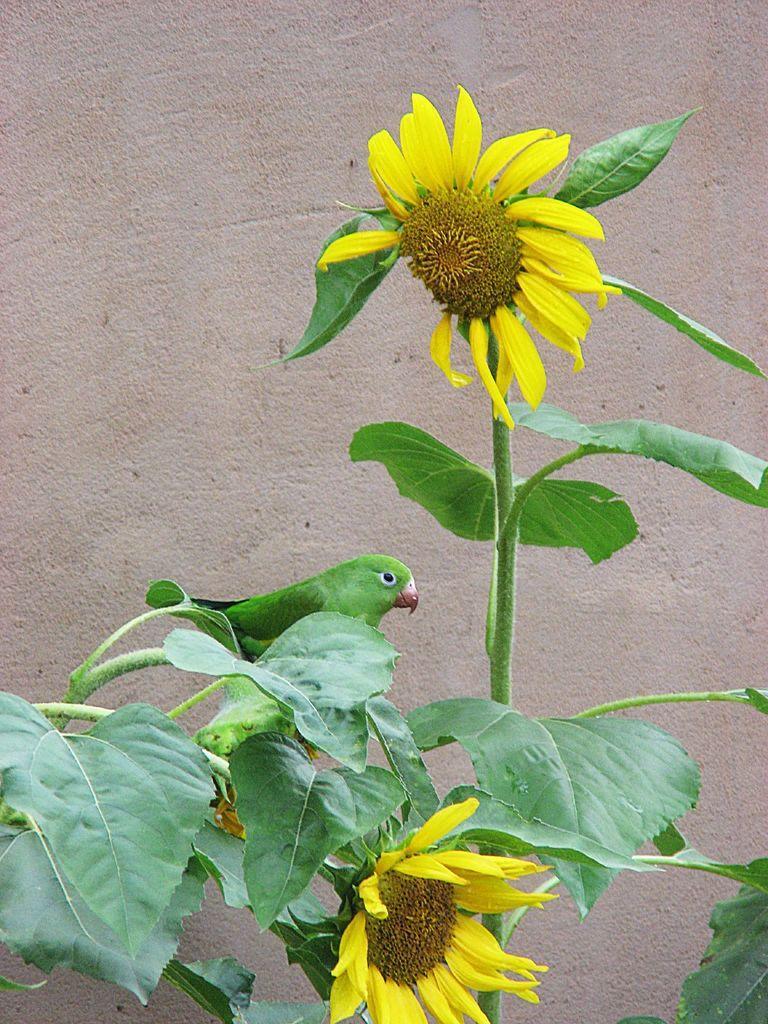How would you summarize this image in a sentence or two? In the image there are flowers to a plant and there is a bird sitting on the branch of a plant, in the background there is a wall. 